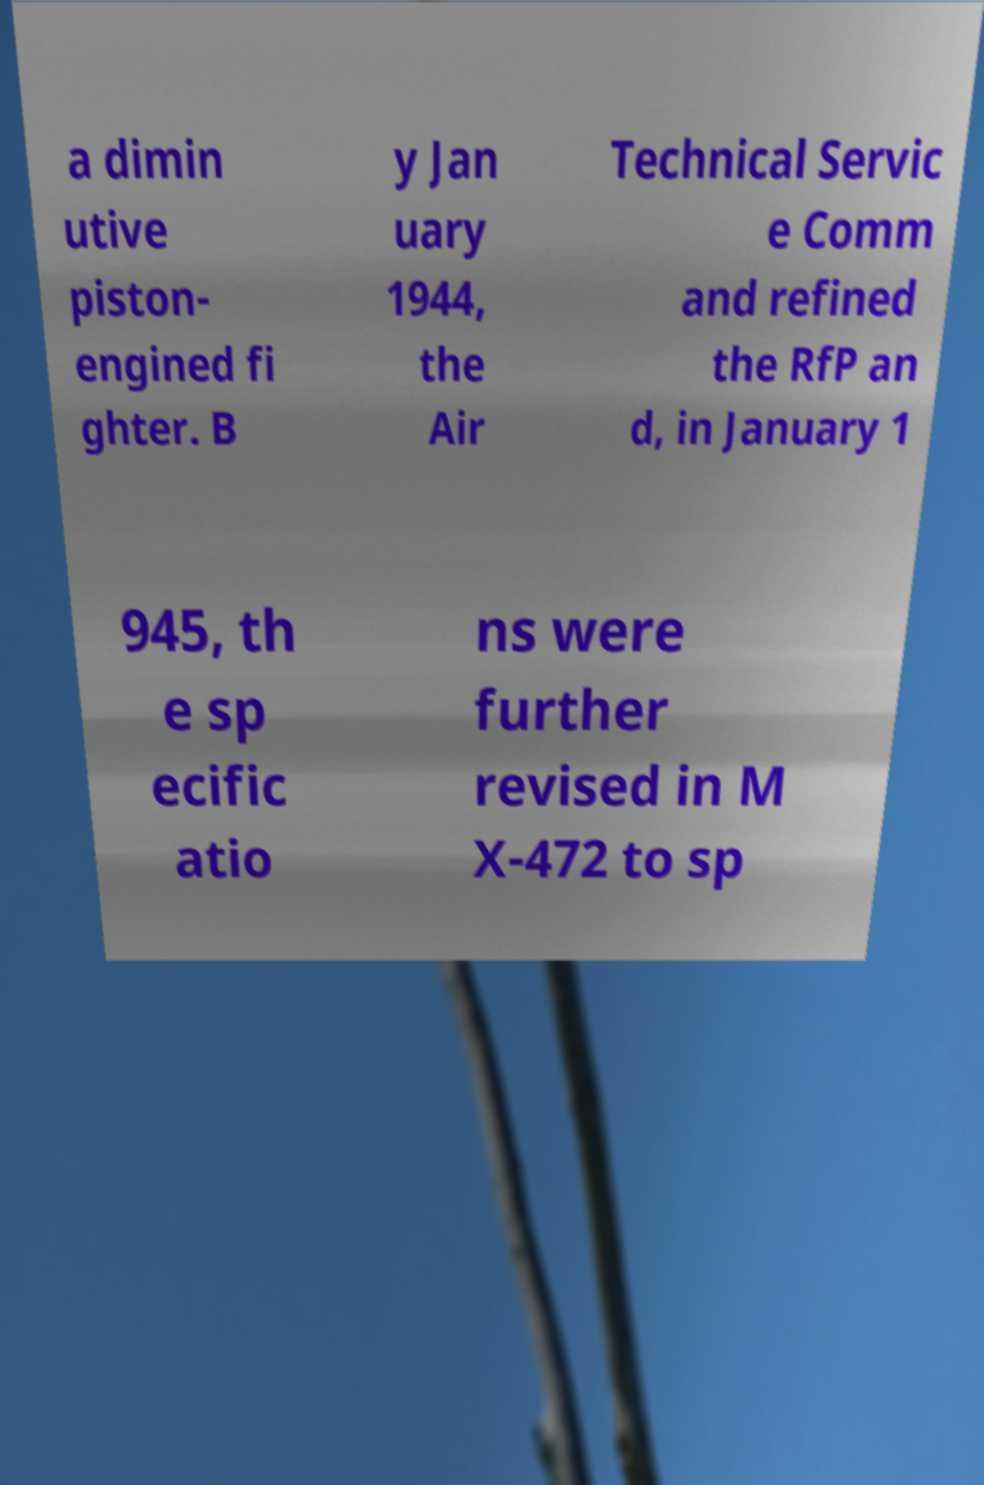For documentation purposes, I need the text within this image transcribed. Could you provide that? a dimin utive piston- engined fi ghter. B y Jan uary 1944, the Air Technical Servic e Comm and refined the RfP an d, in January 1 945, th e sp ecific atio ns were further revised in M X-472 to sp 